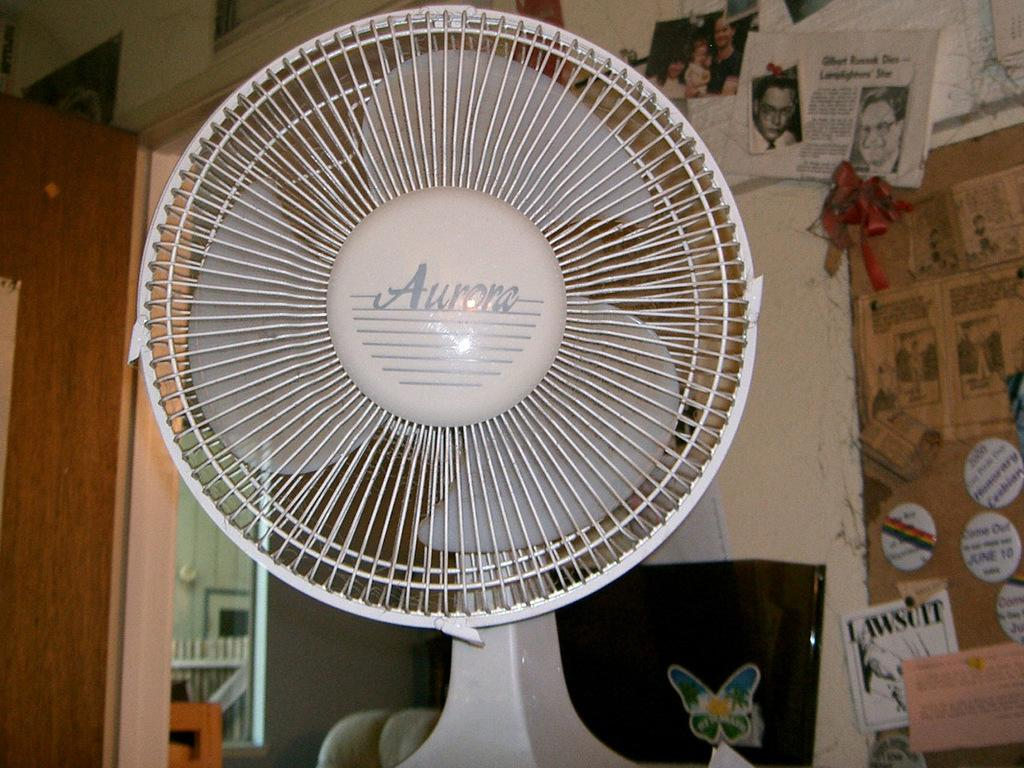What appliance can be seen in the image? There is a fan in the image. What feature is present for entering or exiting a room? There is a door in the image. What can be seen in the background of the image? There is a wall in the background of the image. What decorations are on the wall in the background? There are posters on the wall in the background. Can you hear the bells ringing in the image? There are no bells present in the image, so it is not possible to hear them ringing. 